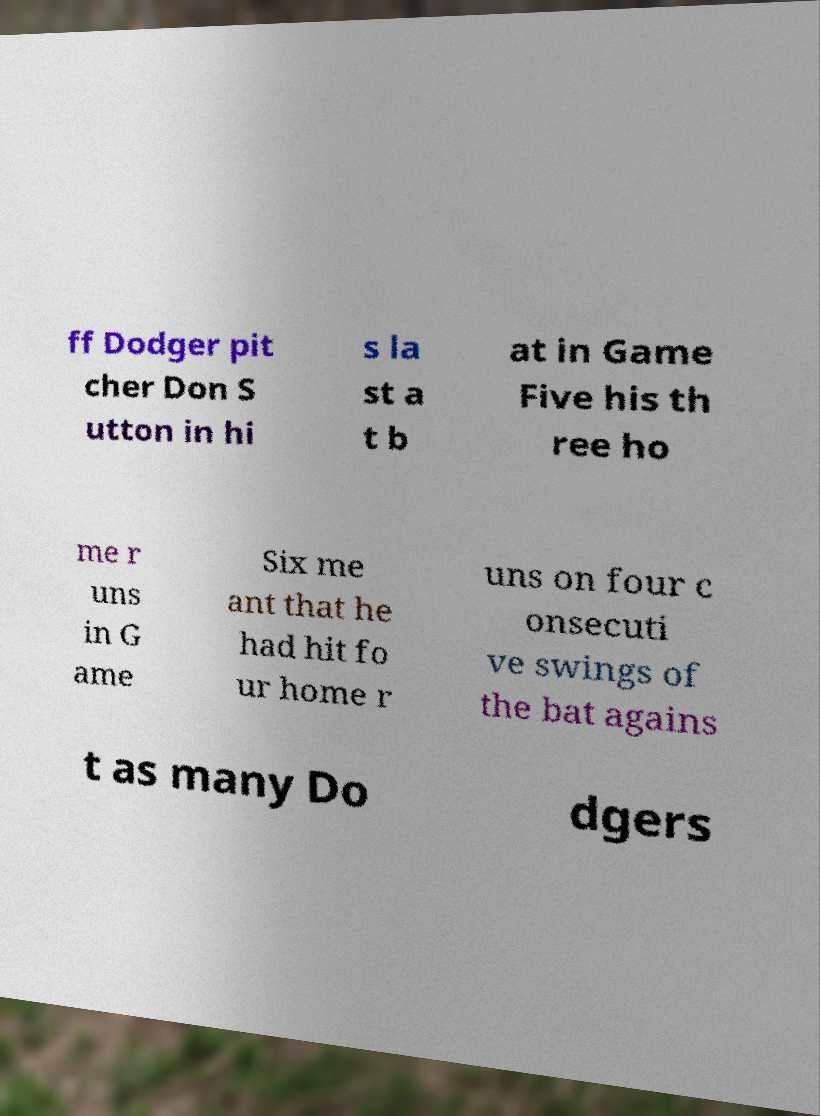For documentation purposes, I need the text within this image transcribed. Could you provide that? ff Dodger pit cher Don S utton in hi s la st a t b at in Game Five his th ree ho me r uns in G ame Six me ant that he had hit fo ur home r uns on four c onsecuti ve swings of the bat agains t as many Do dgers 